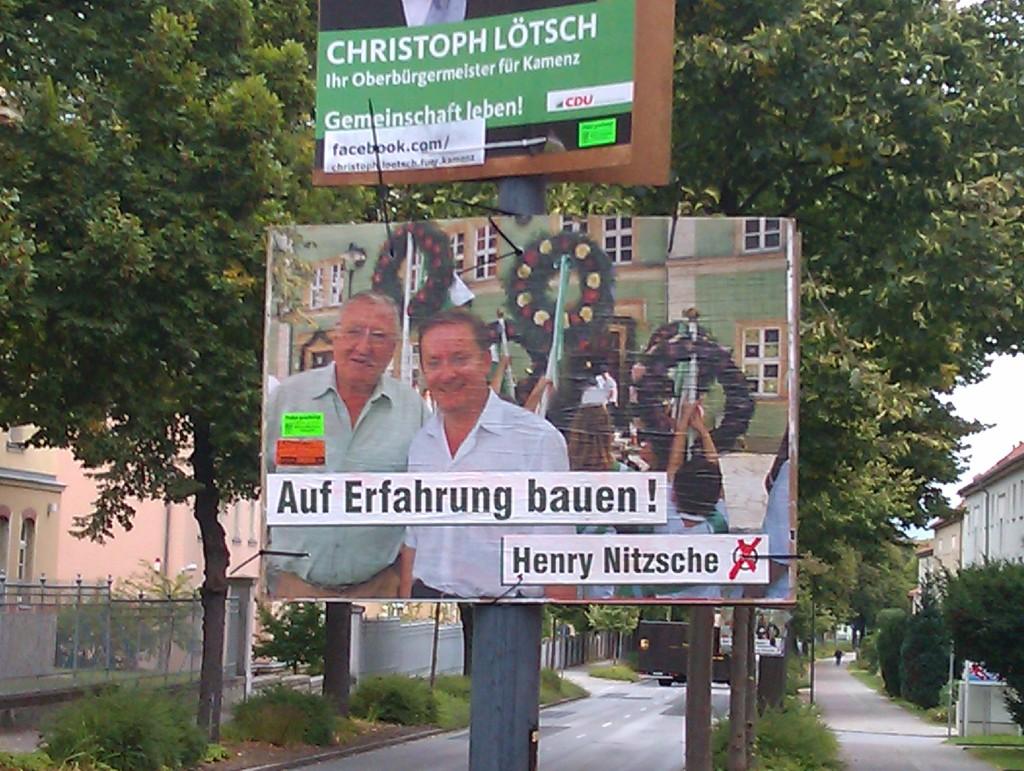What is on the billboard?
Provide a succinct answer. Auf erfahrung bauen. What name is on the top of the picture?
Make the answer very short. Christoph lotsch. 